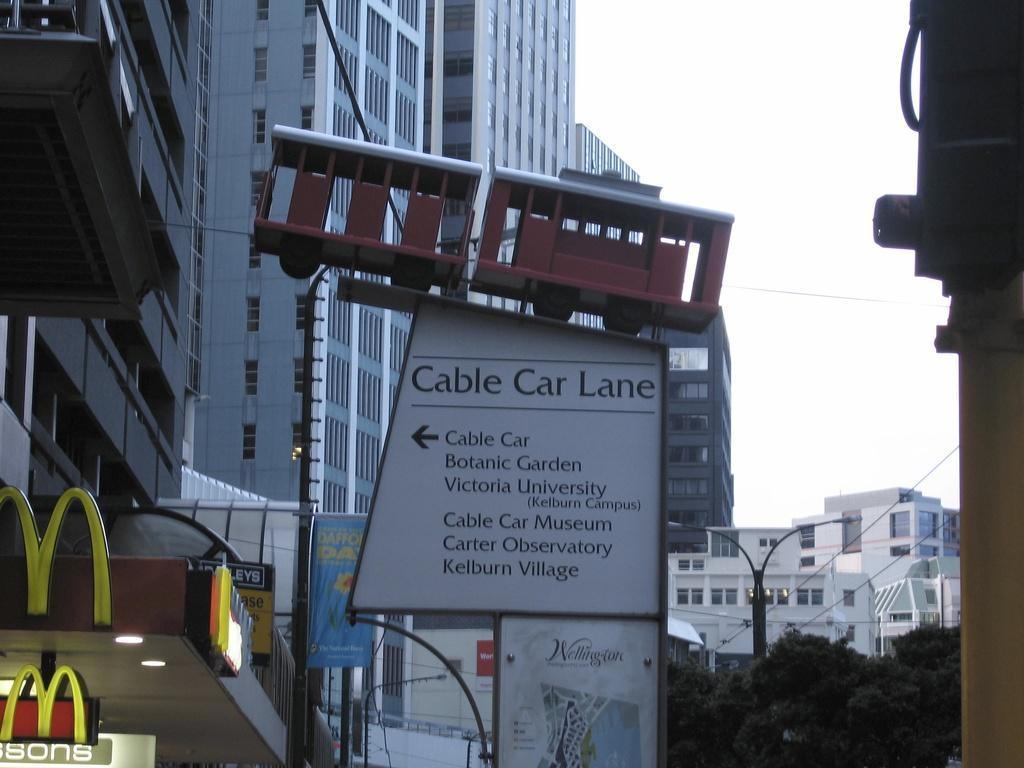Can you describe this image briefly? In this image we can see many buildings and skyscrapers. There is a directional board and few advertising boards in the image. There are many trees in the image. There is a store and a street light in the image. 